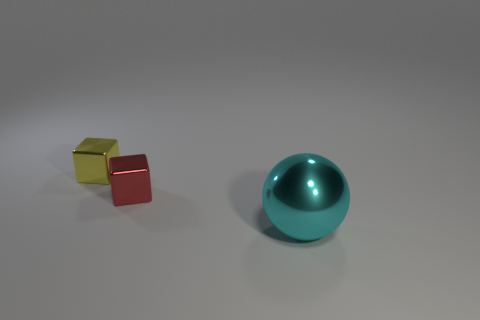Is there a matte thing that has the same shape as the tiny red metallic thing?
Offer a terse response. No. What number of cubes have the same material as the cyan thing?
Offer a terse response. 2. Is the material of the block right of the yellow metallic object the same as the small yellow thing?
Your answer should be compact. Yes. Are there more small metallic objects in front of the tiny yellow cube than cyan shiny objects in front of the cyan shiny thing?
Provide a short and direct response. Yes. What material is the thing that is the same size as the red shiny cube?
Give a very brief answer. Metal. What number of other objects are the same material as the small yellow thing?
Ensure brevity in your answer.  2. There is a metallic thing to the right of the red metallic object; is it the same shape as the tiny thing behind the tiny red shiny block?
Your response must be concise. No. What number of other things are there of the same color as the large metallic object?
Offer a terse response. 0. Is the material of the small block behind the small red shiny object the same as the tiny block that is in front of the small yellow metallic thing?
Make the answer very short. Yes. Are there an equal number of big objects to the right of the cyan object and yellow shiny blocks on the right side of the yellow metallic object?
Make the answer very short. Yes. 